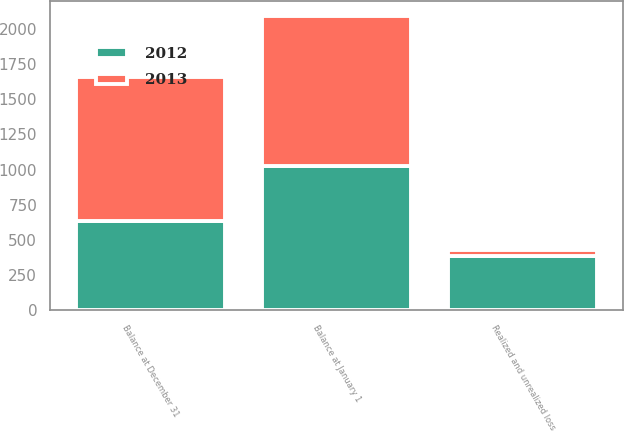Convert chart to OTSL. <chart><loc_0><loc_0><loc_500><loc_500><stacked_bar_chart><ecel><fcel>Balance at January 1<fcel>Realized and unrealized loss<fcel>Balance at December 31<nl><fcel>2012<fcel>1022<fcel>387<fcel>635<nl><fcel>2013<fcel>1067<fcel>45<fcel>1022<nl></chart> 